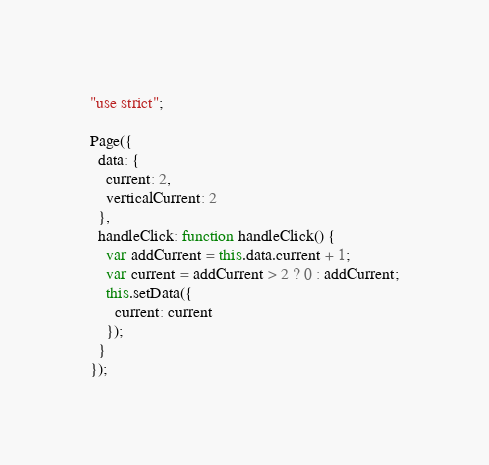<code> <loc_0><loc_0><loc_500><loc_500><_JavaScript_>"use strict";

Page({
  data: {
    current: 2,
    verticalCurrent: 2
  },
  handleClick: function handleClick() {
    var addCurrent = this.data.current + 1;
    var current = addCurrent > 2 ? 0 : addCurrent;
    this.setData({
      current: current
    });
  }
});</code> 